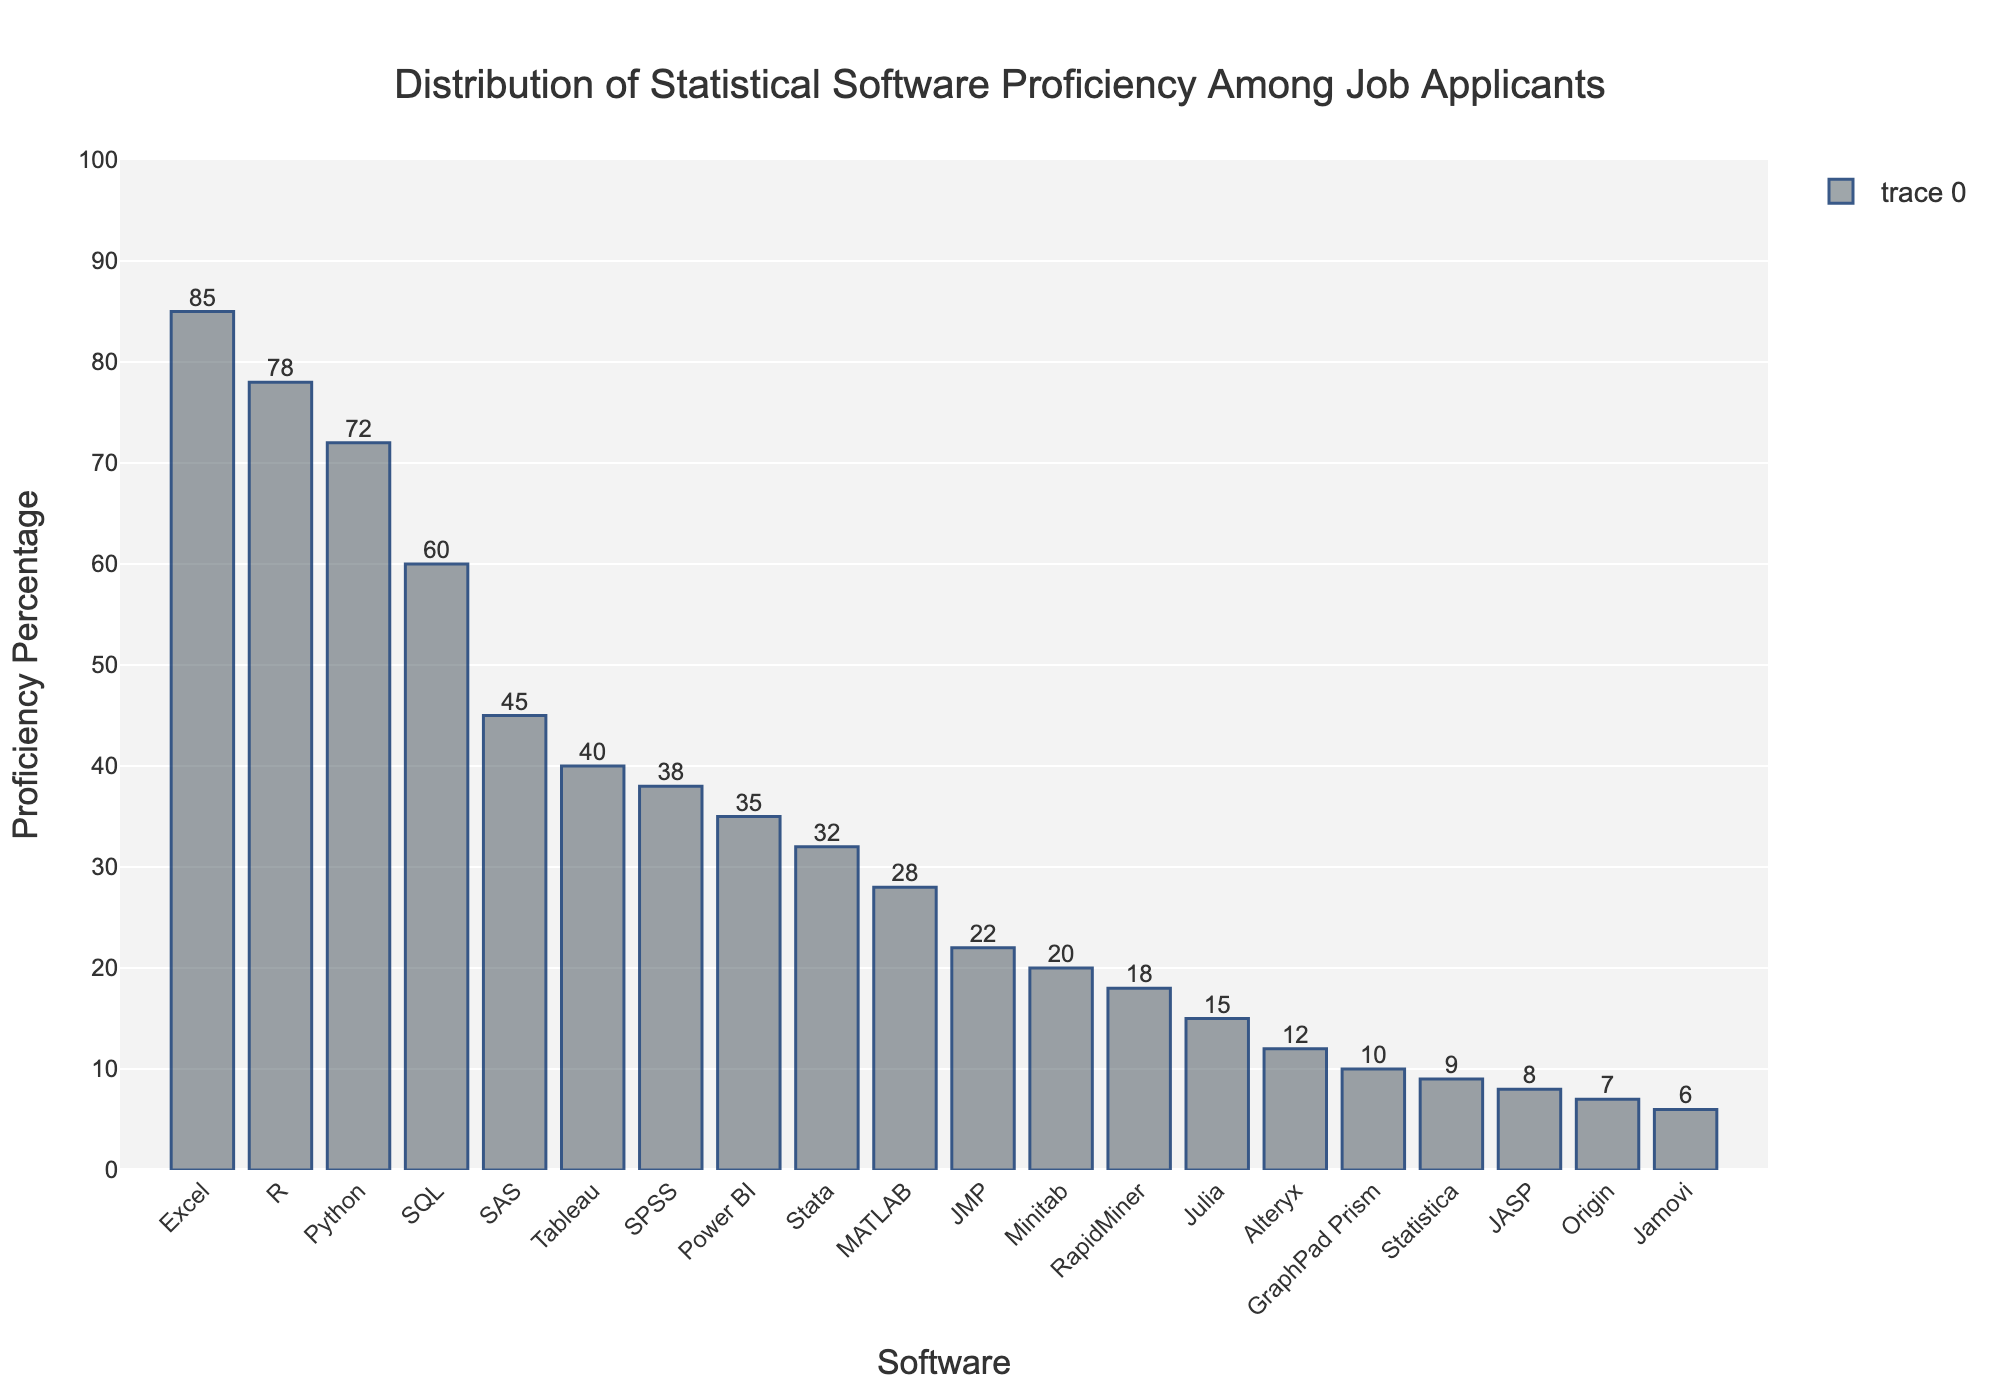Which software has the highest proficiency percentage? Excel has the highest bar height, indicating the highest proficiency percentage among job applicants. The height of each bar corresponds to the proficiency percentage, and Excel's bar is the tallest.
Answer: Excel Which software has the lowest proficiency percentage? The lowest bar belongs to Jamovi, indicating it has the lowest proficiency percentage among job applicants. By comparing the bar heights, Jamovi has the shortest one.
Answer: Jamovi How much higher is the proficiency percentage for R compared to Stata? The proficiency percentage for R is 78%, while for Stata, it is 32%. The difference can be found by subtracting Stata's percentage from R's percentage, which is 78 - 32 = 46.
Answer: 46 What is the average proficiency percentage for Python, SAS, and SPSS? Adding the proficiency percentages for Python (72%), SAS (45%), and SPSS (38%) and dividing by 3 yields the average. (72 + 45 + 38) / 3 = 155 / 3 ≈ 51.67
Answer: 51.67 Are there more applicants proficient in SQL or Tableau? By comparing the bar heights, SQL has a higher proficiency percentage (60%) compared to Tableau (40%).
Answer: SQL Which software has a proficiency percentage closest to 30%? Stata has a proficiency percentage of 32%, which is the closest to 30% among all the software listed. By examining the bar heights near the 30% mark, Stata is identified as closest.
Answer: Stata How many software have a proficiency percentage greater than 50%? By visually inspecting the bars that exceed the 50% line on the y-axis, there are four software: R, Python, Excel, and SQL.
Answer: 4 What's the difference in proficiency percentage between the highest and lowest scored software? Excel has the highest proficiency percentage at 85%, and Jamovi has the lowest at 6%. The difference is calculated as 85 - 6 = 79.
Answer: 79 What is the total proficiency percentage for Excel, Power BI, and MATLAB? Adding the proficiency percentages for Excel (85%), Power BI (35%), and MATLAB (28%) results in 85 + 35 + 28 = 148.
Answer: 148 